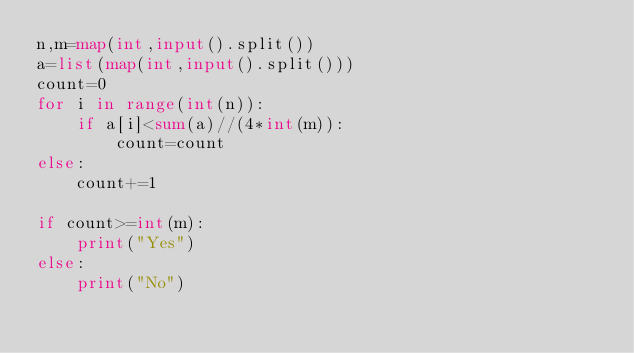<code> <loc_0><loc_0><loc_500><loc_500><_Python_>n,m=map(int,input().split())
a=list(map(int,input().split()))
count=0
for i in range(int(n)):
    if a[i]<sum(a)//(4*int(m)):
        count=count
else:
    count+=1

if count>=int(m):
    print("Yes")
else:
    print("No")</code> 